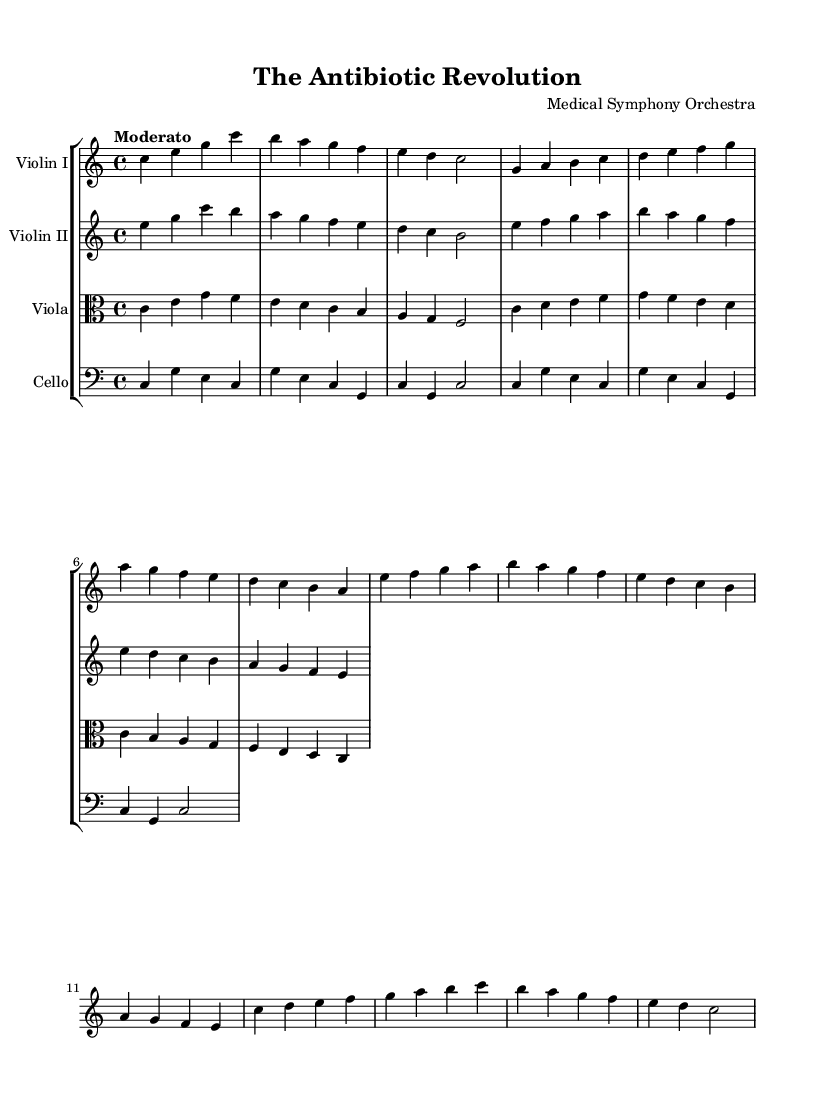What is the key signature of this music? The key signature is C major, which has no sharps or flats.
Answer: C major What is the time signature of the piece? The time signature is indicated at the beginning and shows that each measure contains four beats, represented by 4/4.
Answer: 4/4 What is the tempo marking for this symphony? The tempo marking is indicated at the start with the word "Moderato," which instructs the musicians to play at a moderate pace.
Answer: Moderato How many themes are present in this composition? The composition features three distinct themes: Theme A (Discovery), Theme B (Development), and Theme C (Implementation).
Answer: Three Which instrument plays the simple part in this piece? The simplified part is played by the Violin II, as indicated in the sheet music by its discrete melodic entries.
Answer: Violin II What is the last note value of the Violin I melody? The last note is a half note, indicated by the notation in the final measure of the Violin I part, which is sustained longer than quarter notes.
Answer: Half note What does the cello section primarily contribute to the symphony? The cello section primarily provides a foundational harmonic support with a consistent pattern that complements the higher strings.
Answer: Harmonic support 